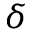Convert formula to latex. <formula><loc_0><loc_0><loc_500><loc_500>\delta</formula> 